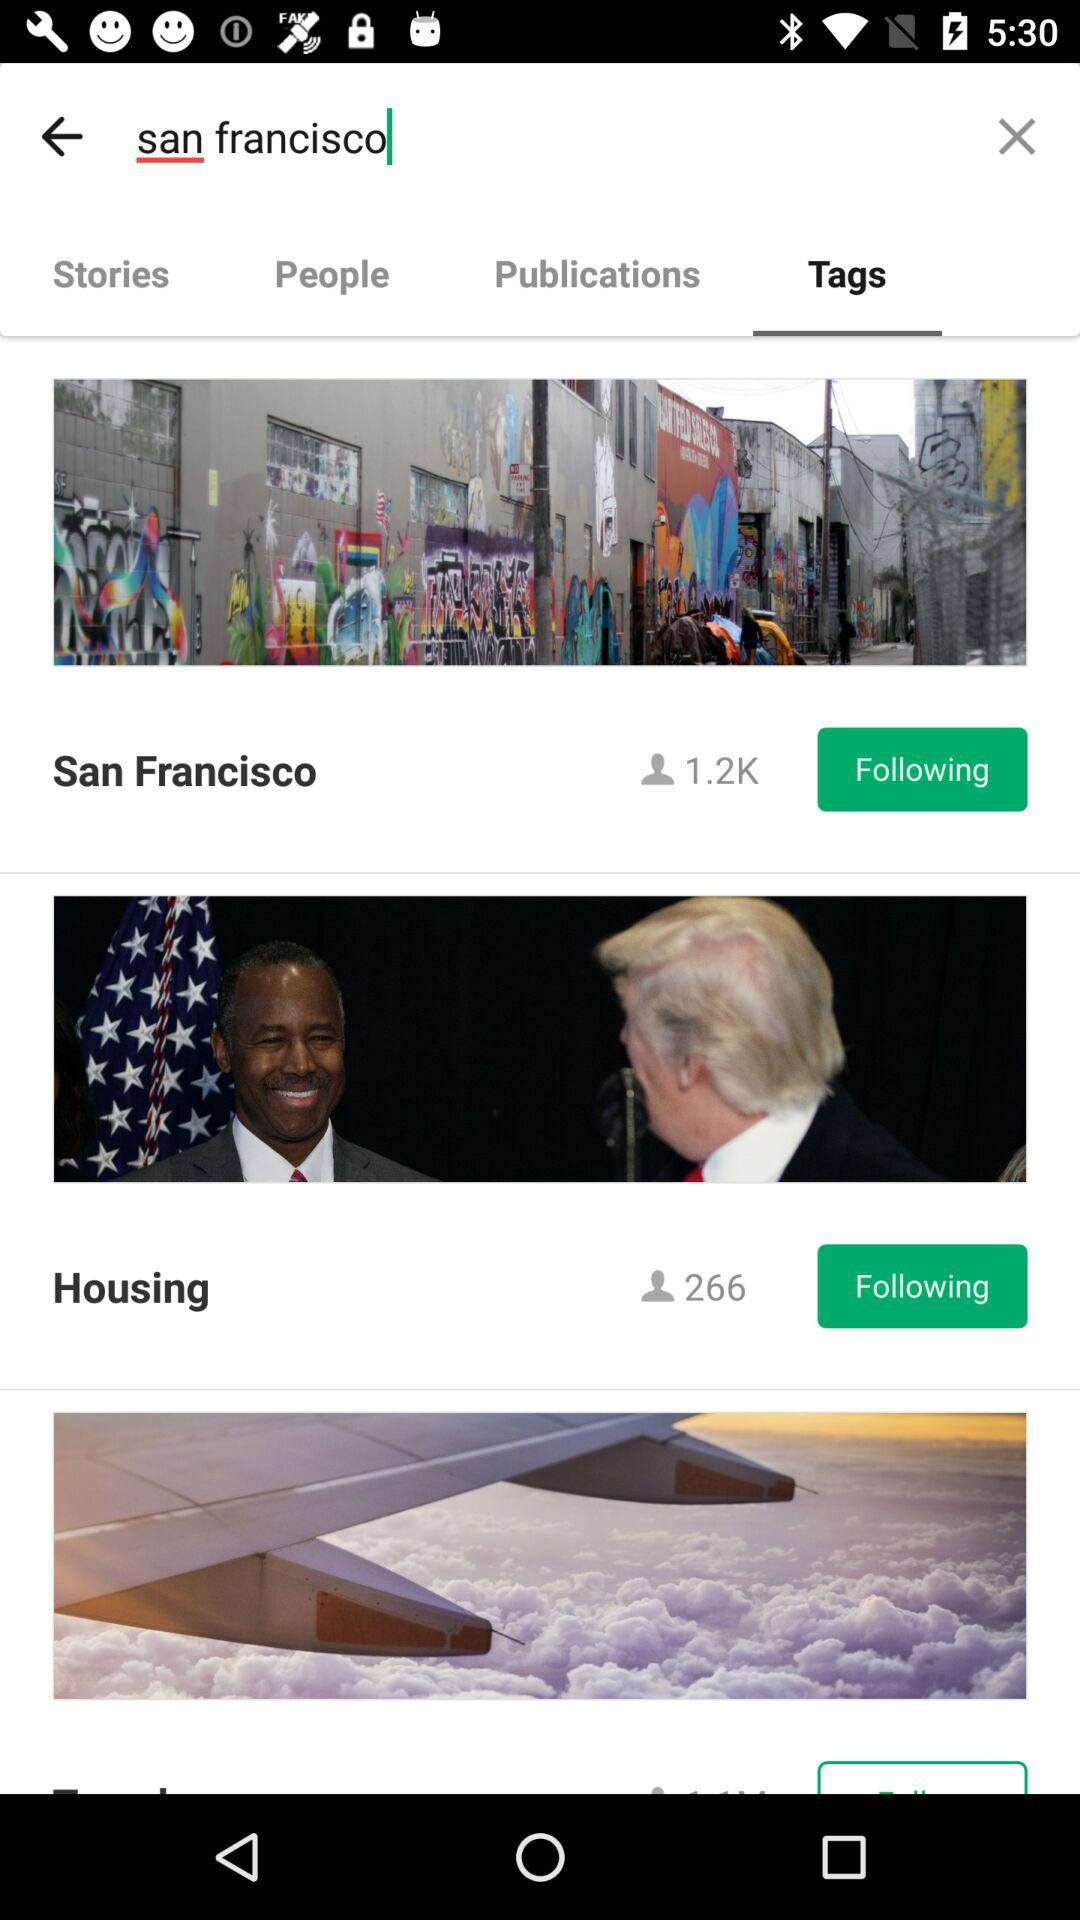How many people are following San Francisco? There are 1.2K people who are following San Francisco. 